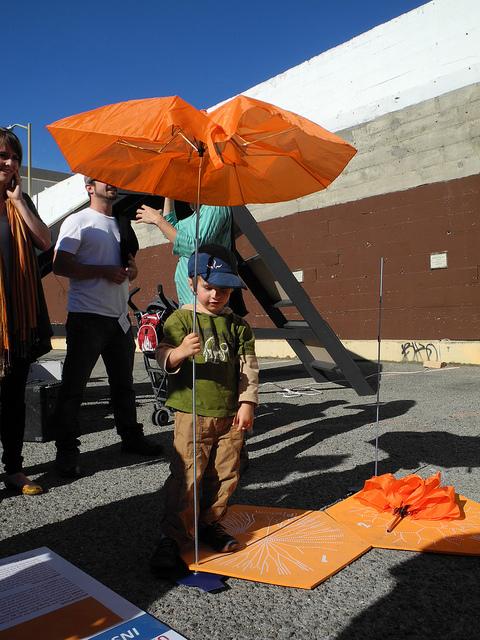Why is there an umbrella?
Write a very short answer. Shade. Was this photo taken near midday?
Quick response, please. Yes. What is the child holding?
Keep it brief. Umbrella. 